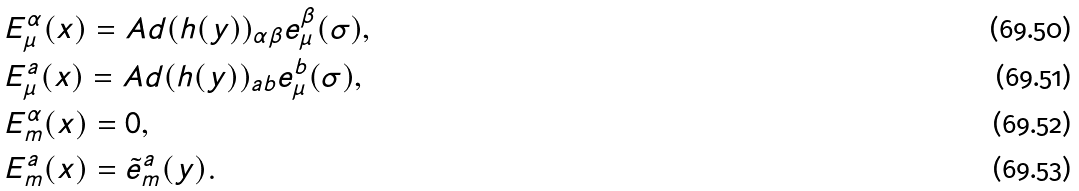<formula> <loc_0><loc_0><loc_500><loc_500>& E ^ { \alpha } _ { \mu } ( x ) = A d ( h ( y ) ) _ { \alpha \beta } e ^ { \beta } _ { \mu } ( \sigma ) , \\ & E ^ { a } _ { \mu } ( x ) = A d ( h ( y ) ) _ { a b } e ^ { b } _ { \mu } ( \sigma ) , \\ & E ^ { \alpha } _ { m } ( x ) = 0 , \\ & E ^ { a } _ { m } ( x ) = \tilde { e } ^ { a } _ { m } ( y ) .</formula> 